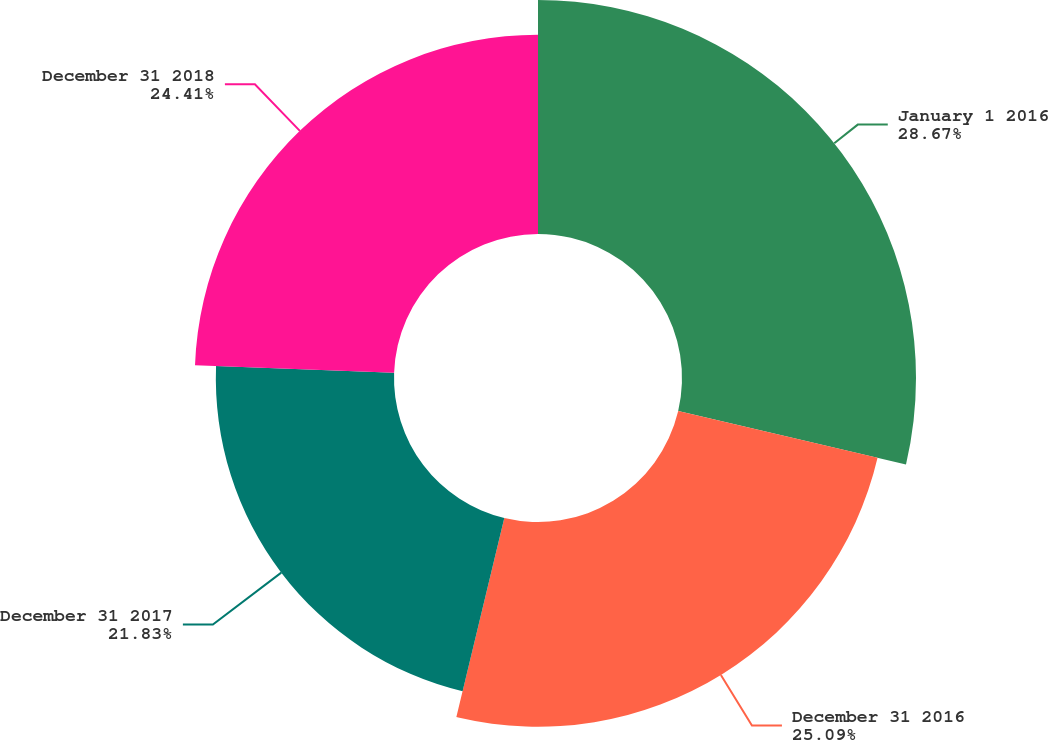<chart> <loc_0><loc_0><loc_500><loc_500><pie_chart><fcel>January 1 2016<fcel>December 31 2016<fcel>December 31 2017<fcel>December 31 2018<nl><fcel>28.67%<fcel>25.09%<fcel>21.83%<fcel>24.41%<nl></chart> 